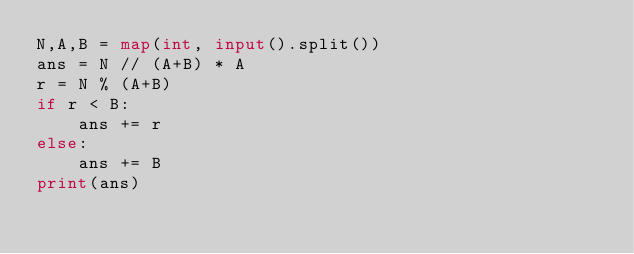<code> <loc_0><loc_0><loc_500><loc_500><_Python_>N,A,B = map(int, input().split())
ans = N // (A+B) * A
r = N % (A+B)
if r < B:
    ans += r
else:
    ans += B
print(ans)</code> 